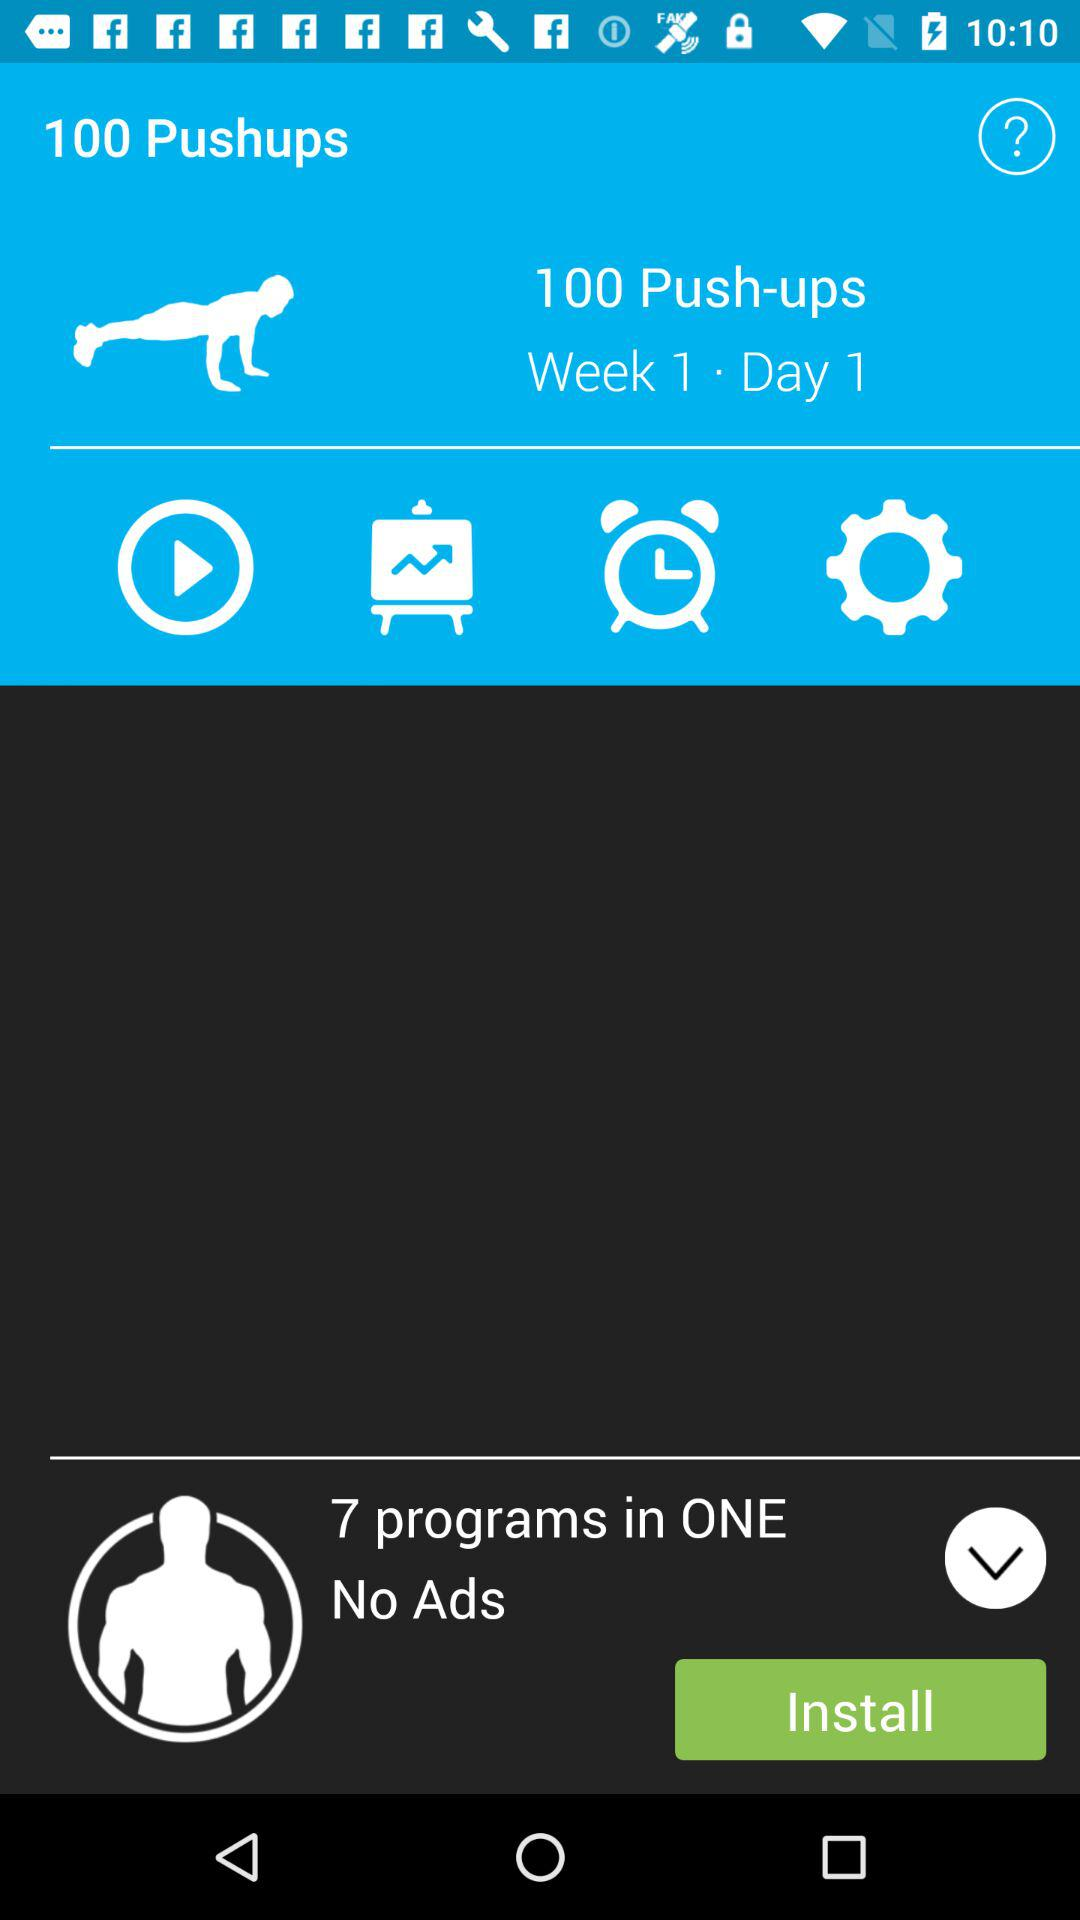How many programs are included in the app?
Answer the question using a single word or phrase. 7 